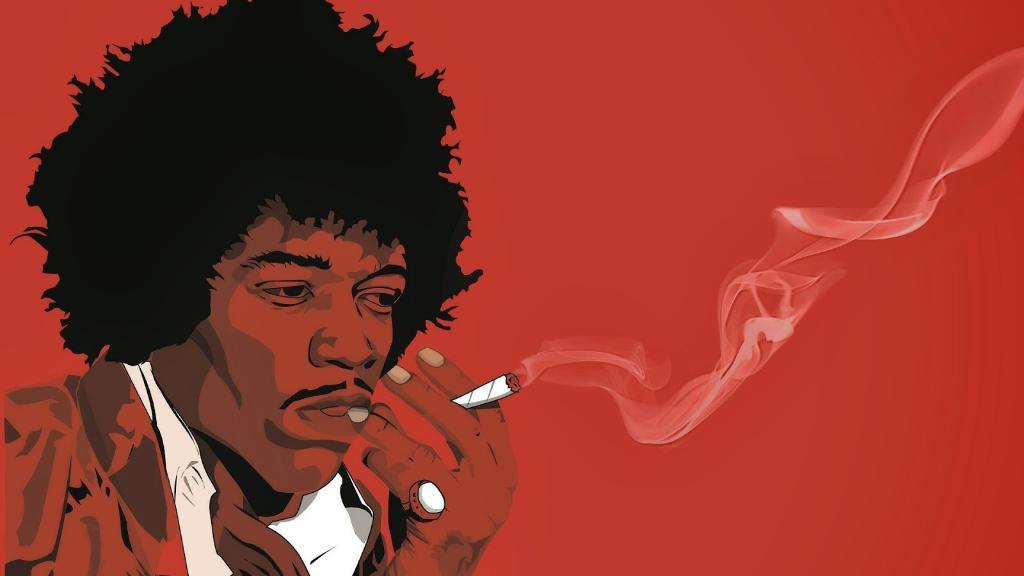What is present in the image? There is a man in the image. What is the man doing in the image? The man is smoking in the image. Can you describe the style of the image? The image appears to be an animation. What route does the cobweb take in the image? There is no cobweb present in the image. How does the pump contribute to the scene in the image? There is no pump present in the image. 